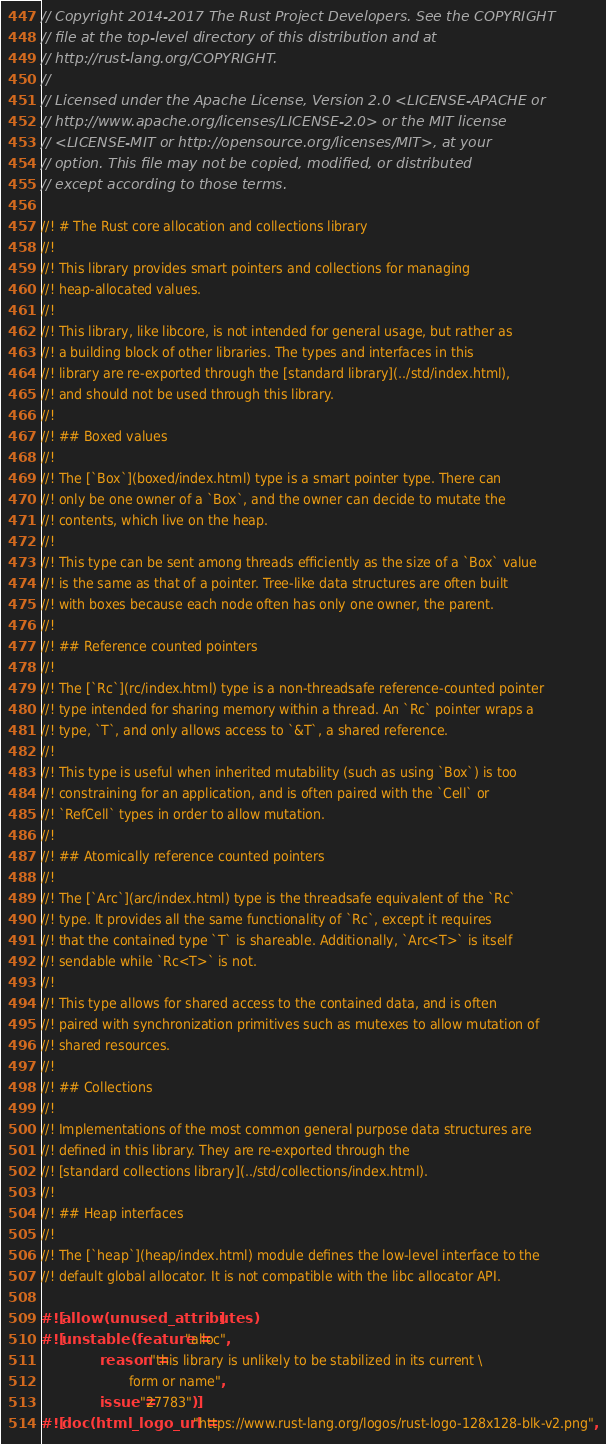<code> <loc_0><loc_0><loc_500><loc_500><_Rust_>// Copyright 2014-2017 The Rust Project Developers. See the COPYRIGHT
// file at the top-level directory of this distribution and at
// http://rust-lang.org/COPYRIGHT.
//
// Licensed under the Apache License, Version 2.0 <LICENSE-APACHE or
// http://www.apache.org/licenses/LICENSE-2.0> or the MIT license
// <LICENSE-MIT or http://opensource.org/licenses/MIT>, at your
// option. This file may not be copied, modified, or distributed
// except according to those terms.

//! # The Rust core allocation and collections library
//!
//! This library provides smart pointers and collections for managing
//! heap-allocated values.
//!
//! This library, like libcore, is not intended for general usage, but rather as
//! a building block of other libraries. The types and interfaces in this
//! library are re-exported through the [standard library](../std/index.html),
//! and should not be used through this library.
//!
//! ## Boxed values
//!
//! The [`Box`](boxed/index.html) type is a smart pointer type. There can
//! only be one owner of a `Box`, and the owner can decide to mutate the
//! contents, which live on the heap.
//!
//! This type can be sent among threads efficiently as the size of a `Box` value
//! is the same as that of a pointer. Tree-like data structures are often built
//! with boxes because each node often has only one owner, the parent.
//!
//! ## Reference counted pointers
//!
//! The [`Rc`](rc/index.html) type is a non-threadsafe reference-counted pointer
//! type intended for sharing memory within a thread. An `Rc` pointer wraps a
//! type, `T`, and only allows access to `&T`, a shared reference.
//!
//! This type is useful when inherited mutability (such as using `Box`) is too
//! constraining for an application, and is often paired with the `Cell` or
//! `RefCell` types in order to allow mutation.
//!
//! ## Atomically reference counted pointers
//!
//! The [`Arc`](arc/index.html) type is the threadsafe equivalent of the `Rc`
//! type. It provides all the same functionality of `Rc`, except it requires
//! that the contained type `T` is shareable. Additionally, `Arc<T>` is itself
//! sendable while `Rc<T>` is not.
//!
//! This type allows for shared access to the contained data, and is often
//! paired with synchronization primitives such as mutexes to allow mutation of
//! shared resources.
//!
//! ## Collections
//!
//! Implementations of the most common general purpose data structures are
//! defined in this library. They are re-exported through the
//! [standard collections library](../std/collections/index.html).
//!
//! ## Heap interfaces
//!
//! The [`heap`](heap/index.html) module defines the low-level interface to the
//! default global allocator. It is not compatible with the libc allocator API.

#![allow(unused_attributes)]
#![unstable(feature = "alloc",
            reason = "this library is unlikely to be stabilized in its current \
                      form or name",
            issue = "27783")]
#![doc(html_logo_url = "https://www.rust-lang.org/logos/rust-logo-128x128-blk-v2.png",</code> 